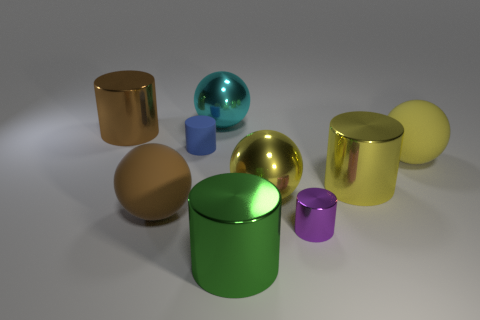Can you describe the lighting in this scene? The lighting in this scene is soft and appears to be coming from above, as indicated by the shadows under the objects. It gives the scene a calm and controlled atmosphere with diffuse shadows suggesting an indoor setting, possibly a studio setup. 